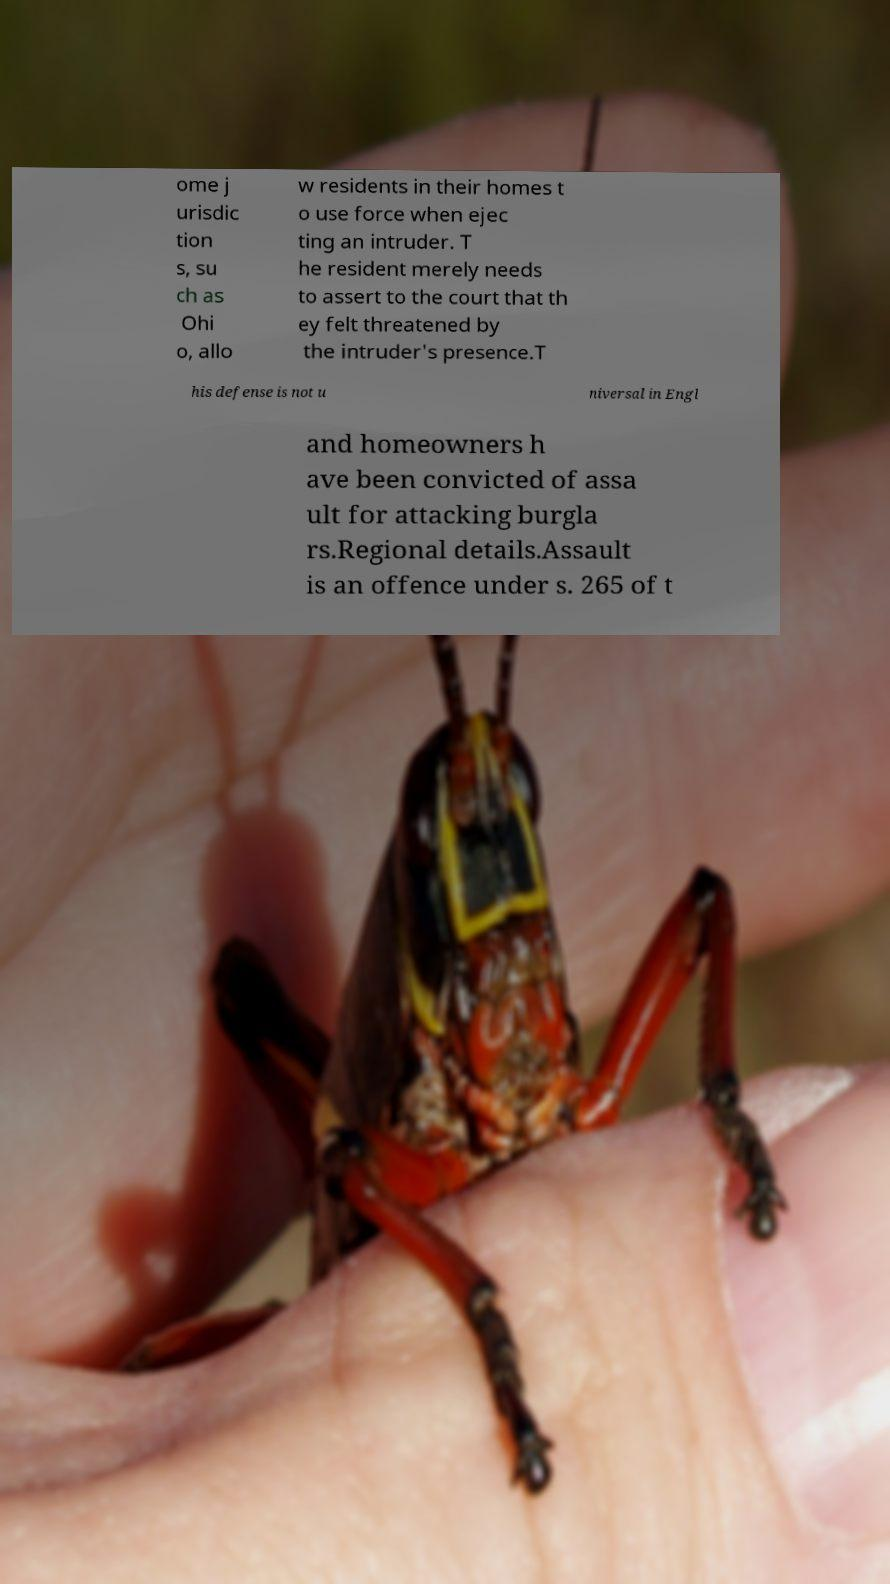I need the written content from this picture converted into text. Can you do that? ome j urisdic tion s, su ch as Ohi o, allo w residents in their homes t o use force when ejec ting an intruder. T he resident merely needs to assert to the court that th ey felt threatened by the intruder's presence.T his defense is not u niversal in Engl and homeowners h ave been convicted of assa ult for attacking burgla rs.Regional details.Assault is an offence under s. 265 of t 